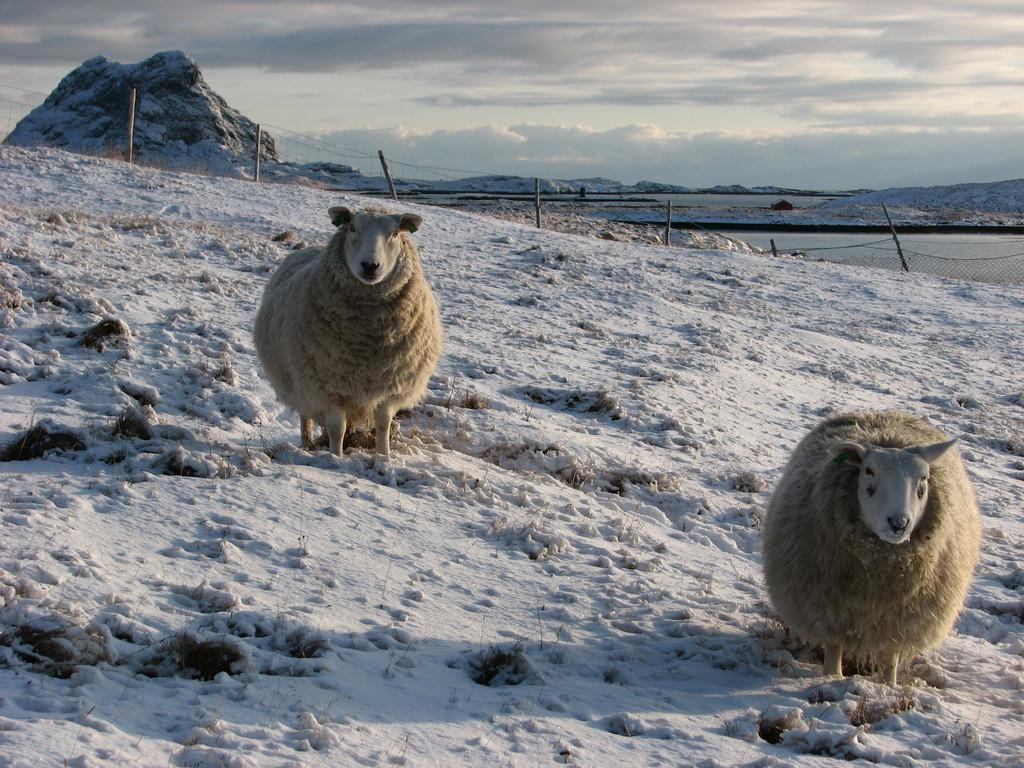What animals can be seen in the image? There are sheep on the ice in the image. What can be seen in the background of the image? There is a net, poles, and hills visible in the background of the image. Where is the kitten located in the image? There is no kitten present in the image. What type of map is visible in the image? There is no map present in the image. 